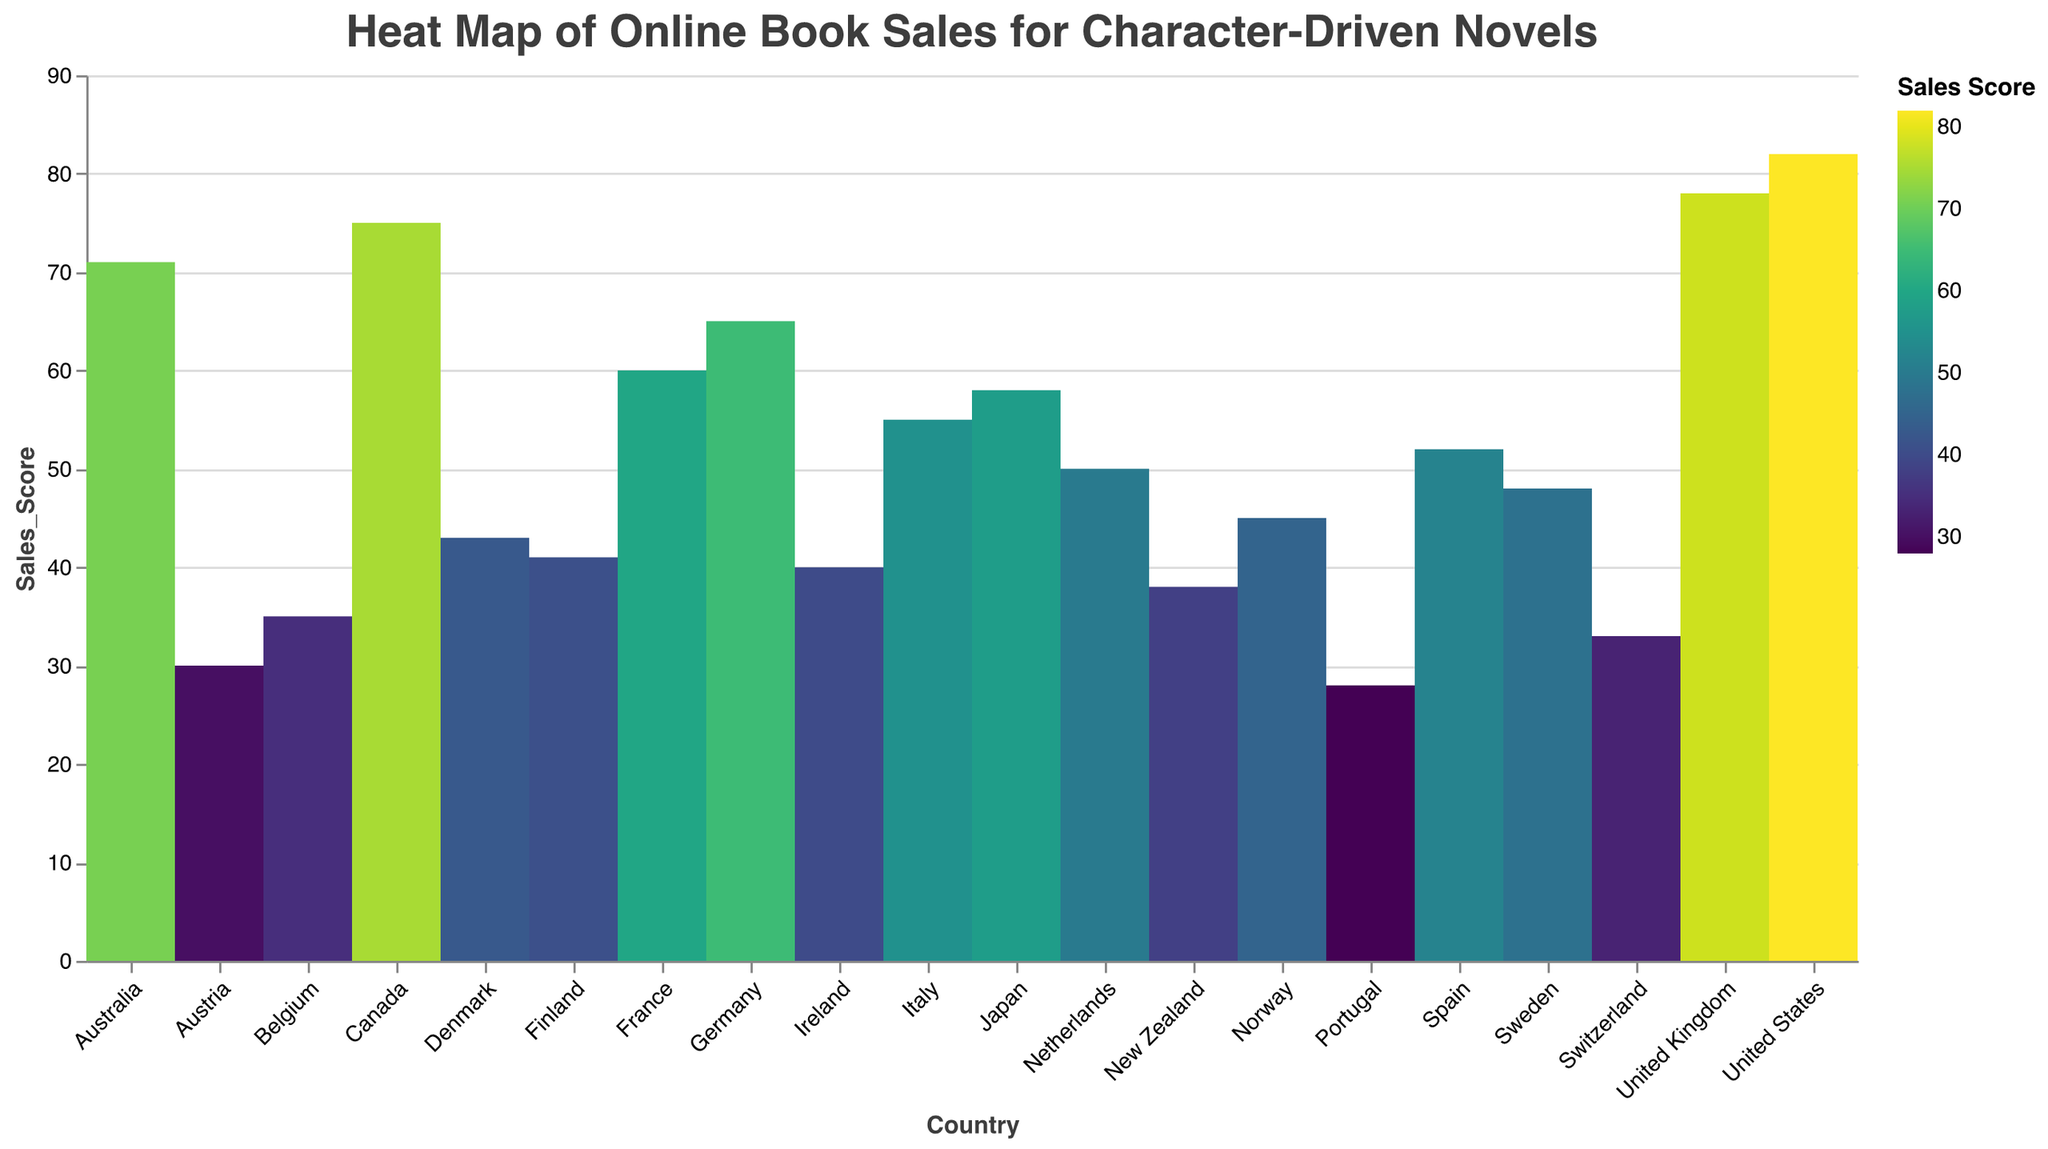What is the title of the heat map? The title is displayed at the top of the heat map and reads "Heat Map of Online Book Sales for Character-Driven Novels".
Answer: Heat Map of Online Book Sales for Character-Driven Novels Which country has the highest sales score? The chart shows each country's sales score, and the United States has the darkest color indicating the highest score of 82.
Answer: United States How many countries are represented in the heat map? Each country is listed on the x-axis. By counting the labels, we can see there are 20 countries represented.
Answer: 20 What is the range of sales scores shown in the heat map? The minimum and maximum sales scores are shown along the y-axis, ranging from Portugal's 28 to the United States' 82.
Answer: 28 to 82 What is the sales score of Japan? By finding Japan on the x-axis and looking up to the corresponding y-axis value, we see Japan's sales score is 58.
Answer: 58 Which country has a higher sales score, Germany or France? Comparing the colors and y-values of Germany and France, Germany has a sales score of 65 and France has 60, so Germany has a higher score.
Answer: Germany What is the average sales score of the top 5 countries? The top 5 countries by sales score are United States (82), United Kingdom (78), Canada (75), Australia (71), and Germany (65). The sum is 82 + 78 + 75 + 71 + 65 = 371. Dividing by 5, the average score is 74.2.
Answer: 74.2 Which countries have sales scores below 40? Checking each country's sales score and filtering those below 40, we find Ireland (40, but not below), New Zealand (38), Belgium (35), Switzerland (33), Austria (30), and Portugal (28).
Answer: New Zealand, Belgium, Switzerland, Austria, Portugal How does the sales score of Spain compare to Italy? Spain has a sales score of 52, whereas Italy has a score of 55. This shows that Italy has a higher sales score than Spain by 3 points.
Answer: Italy has a higher score by 3 points What is the median sales score among all countries? Arranging the 20 sales scores in ascending order: 28, 30, 33, 35, 38, 40, 41, 43, 45, 48, 50, 52, 55, 58, 60, 65, 71, 75, 78, 82. The median is the average of the 10th and 11th scores: (48 + 50)/2 = 49.
Answer: 49 